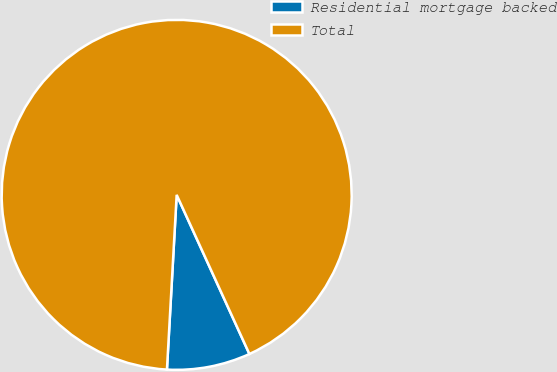<chart> <loc_0><loc_0><loc_500><loc_500><pie_chart><fcel>Residential mortgage backed<fcel>Total<nl><fcel>7.71%<fcel>92.29%<nl></chart> 